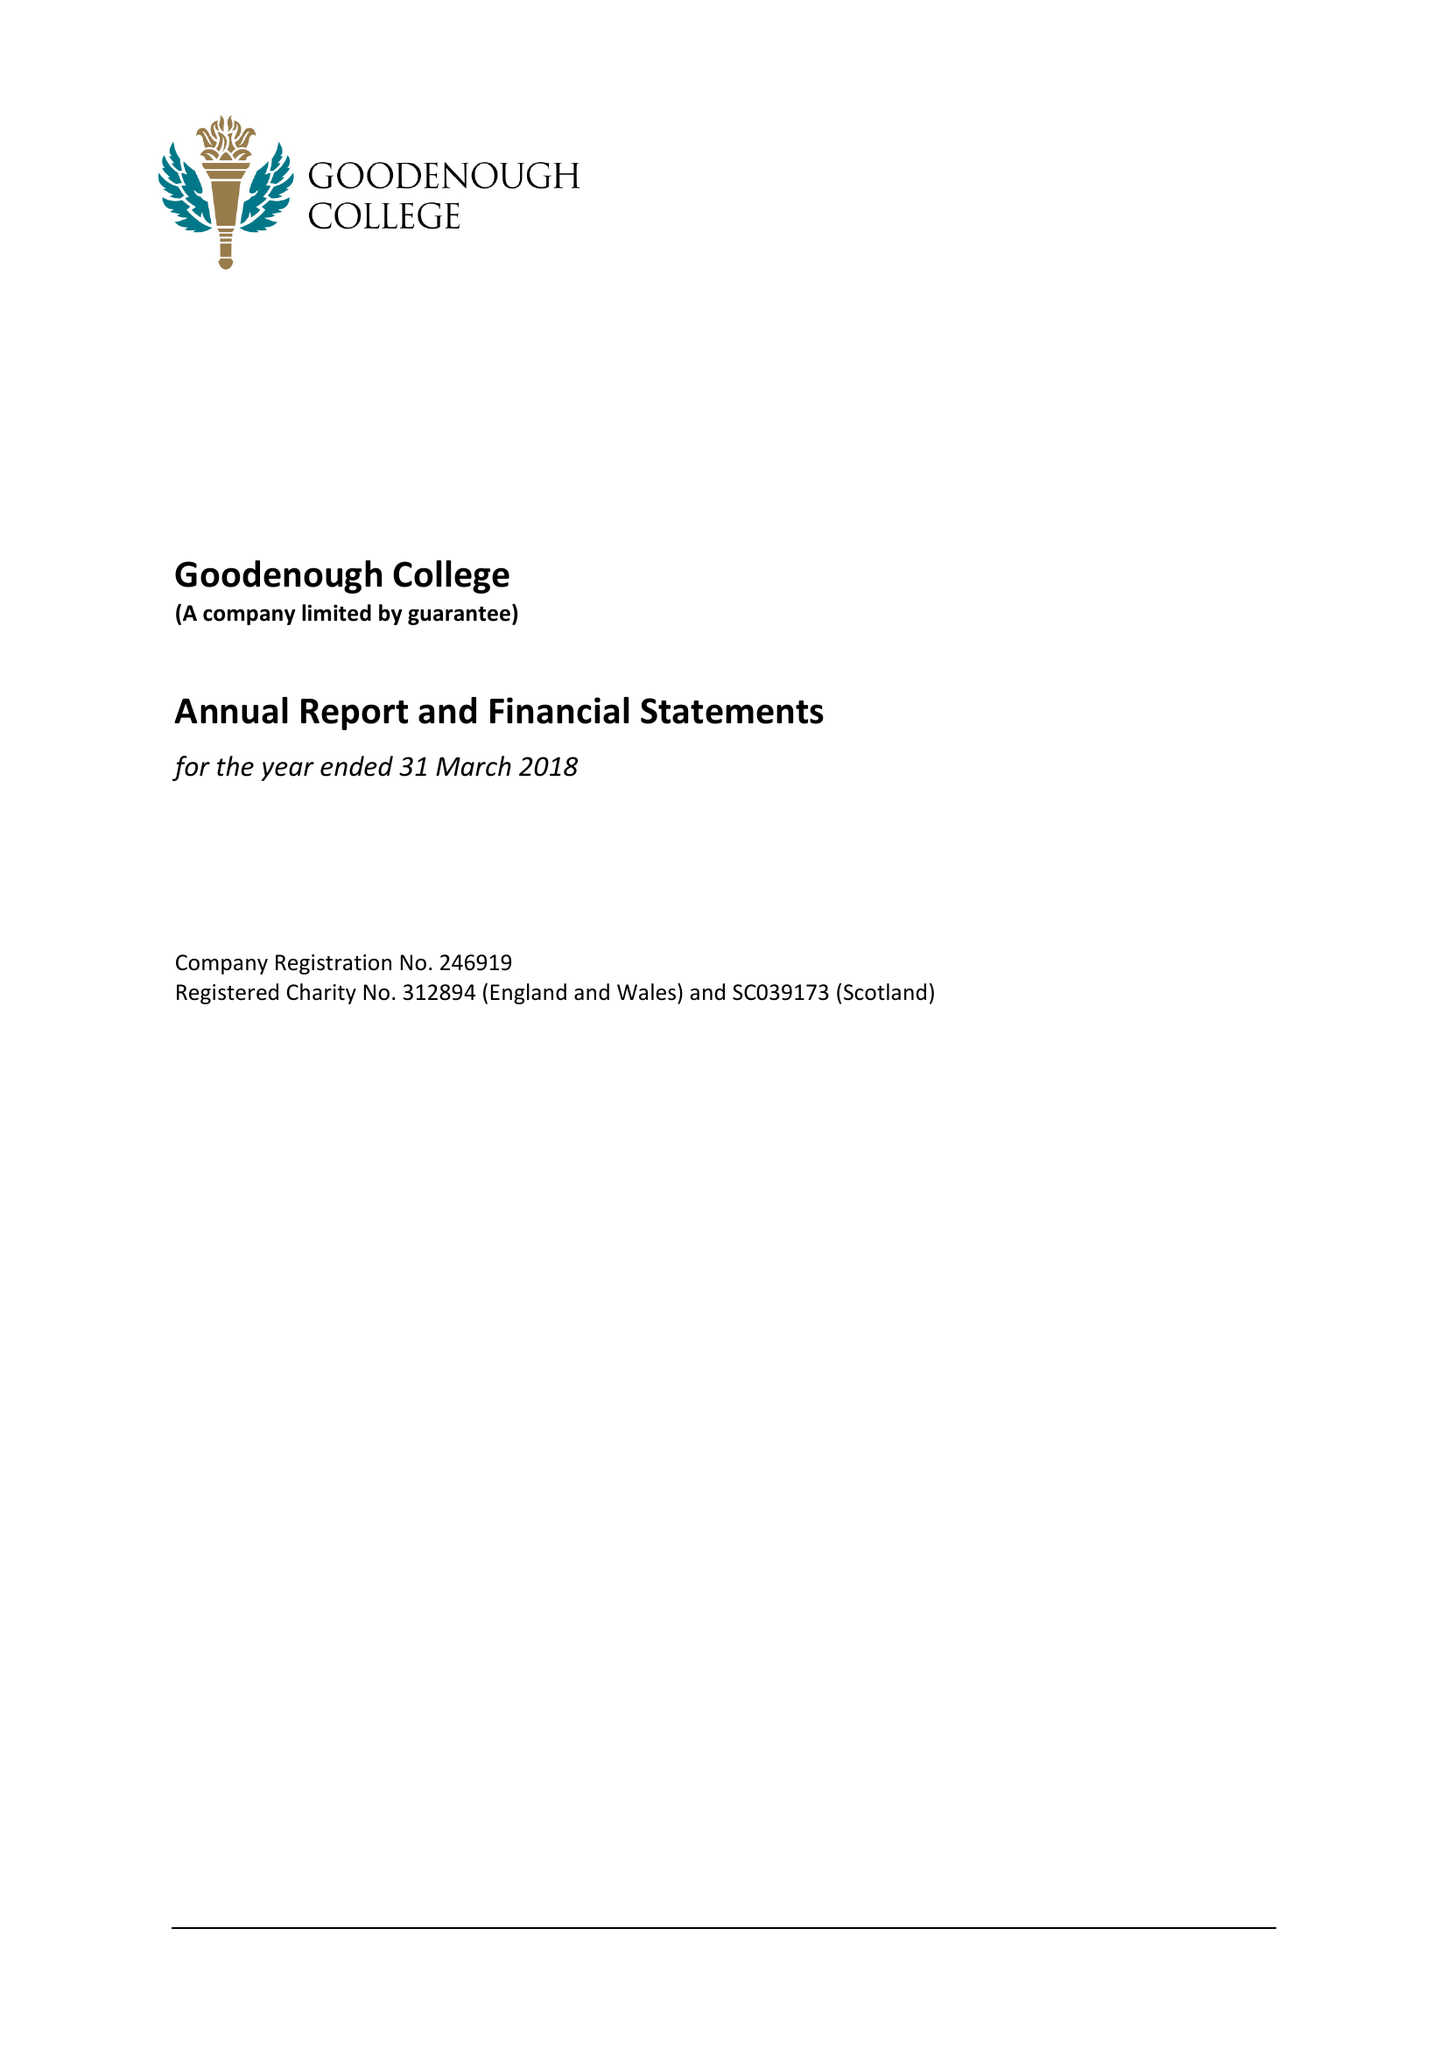What is the value for the address__post_town?
Answer the question using a single word or phrase. LONDON 